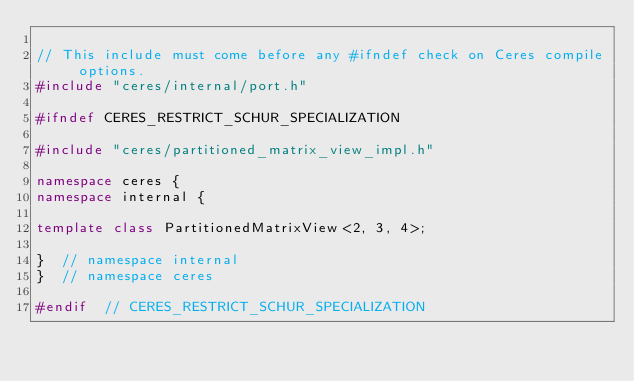Convert code to text. <code><loc_0><loc_0><loc_500><loc_500><_C++_>
// This include must come before any #ifndef check on Ceres compile options.
#include "ceres/internal/port.h"

#ifndef CERES_RESTRICT_SCHUR_SPECIALIZATION

#include "ceres/partitioned_matrix_view_impl.h"

namespace ceres {
namespace internal {

template class PartitionedMatrixView<2, 3, 4>;

}  // namespace internal
}  // namespace ceres

#endif  // CERES_RESTRICT_SCHUR_SPECIALIZATION
</code> 